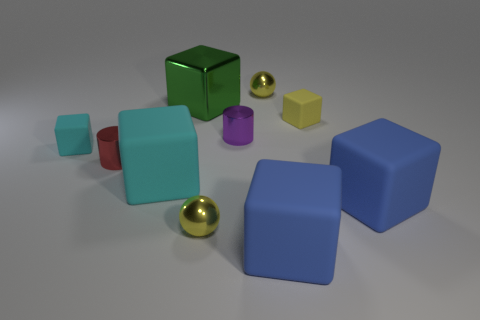What shape is the purple shiny thing that is the same size as the yellow rubber object?
Ensure brevity in your answer.  Cylinder. Is there a small purple object right of the yellow metallic sphere that is on the right side of the yellow sphere that is in front of the small cyan cube?
Your answer should be very brief. No. Are there any blue things of the same size as the green metallic block?
Give a very brief answer. Yes. There is a sphere left of the tiny purple metallic thing; how big is it?
Your response must be concise. Small. There is a metallic ball behind the tiny yellow shiny ball that is to the left of the yellow metallic object behind the large green shiny block; what color is it?
Offer a terse response. Yellow. What is the color of the block that is in front of the tiny yellow ball in front of the large cyan matte cube?
Provide a short and direct response. Blue. Is the number of big blue things that are on the right side of the large cyan cube greater than the number of small purple cylinders that are on the right side of the purple metal thing?
Offer a terse response. Yes. Does the large block that is to the left of the big green block have the same material as the small ball behind the large metal thing?
Your answer should be compact. No. Are there any matte objects to the left of the metal cube?
Your answer should be compact. Yes. What number of yellow objects are either metal balls or shiny cubes?
Your response must be concise. 2. 